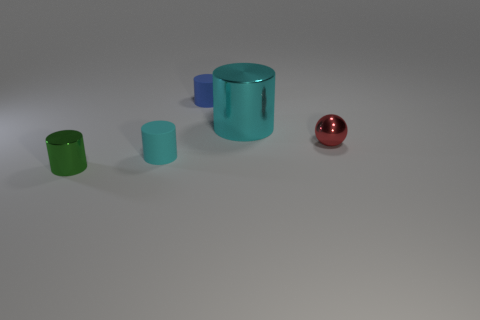Subtract all green shiny cylinders. How many cylinders are left? 3 Add 1 blue objects. How many objects exist? 6 Subtract all gray spheres. How many cyan cylinders are left? 2 Subtract 2 cylinders. How many cylinders are left? 2 Add 5 blue matte things. How many blue matte things are left? 6 Add 3 rubber things. How many rubber things exist? 5 Subtract all cyan cylinders. How many cylinders are left? 2 Subtract 0 green cubes. How many objects are left? 5 Subtract all spheres. How many objects are left? 4 Subtract all green cylinders. Subtract all green blocks. How many cylinders are left? 3 